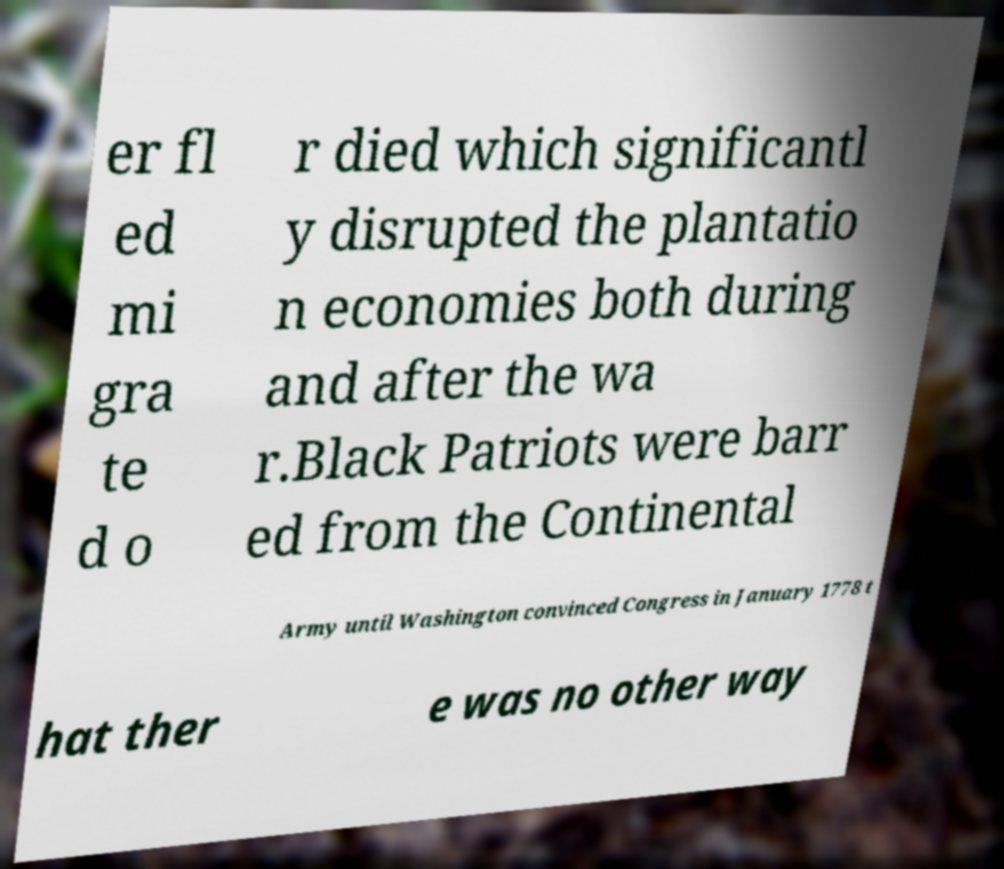Could you assist in decoding the text presented in this image and type it out clearly? er fl ed mi gra te d o r died which significantl y disrupted the plantatio n economies both during and after the wa r.Black Patriots were barr ed from the Continental Army until Washington convinced Congress in January 1778 t hat ther e was no other way 